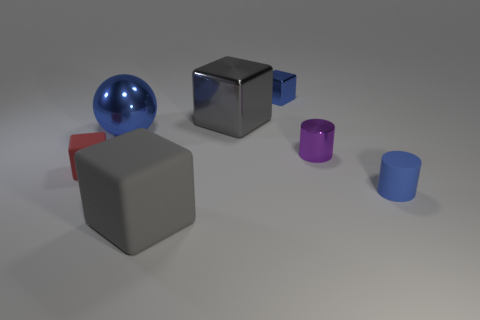There is a block that is the same color as the big ball; what size is it?
Give a very brief answer. Small. There is a rubber block right of the tiny thing to the left of the blue ball; what is its color?
Make the answer very short. Gray. What is the material of the cube in front of the small rubber cylinder?
Give a very brief answer. Rubber. Are there fewer small yellow rubber blocks than blue metal objects?
Your answer should be compact. Yes. There is a large blue thing; is it the same shape as the tiny rubber object behind the blue cylinder?
Your answer should be compact. No. There is a blue object that is both in front of the big metallic cube and on the right side of the large gray rubber thing; what is its shape?
Keep it short and to the point. Cylinder. Is the number of small metallic blocks that are in front of the blue cylinder the same as the number of small blocks that are behind the tiny purple metallic cylinder?
Make the answer very short. No. Is the shape of the shiny object that is right of the tiny blue block the same as  the big gray rubber object?
Your answer should be compact. No. What number of blue things are either big blocks or cylinders?
Offer a very short reply. 1. There is another gray thing that is the same shape as the gray matte thing; what material is it?
Provide a short and direct response. Metal. 